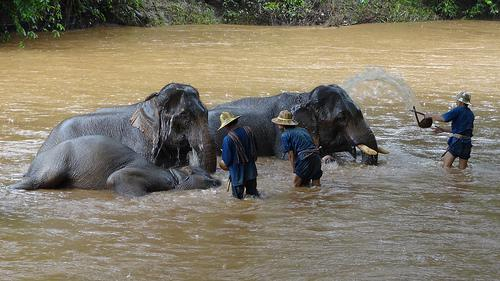Question: how many elephants are there?
Choices:
A. Three.
B. Two.
C. Four.
D. Five.
Answer with the letter. Answer: A Question: what are these people doing?
Choices:
A. Playing soccer.
B. Eating.
C. Riding bicycles.
D. Washing the elephants.
Answer with the letter. Answer: D 